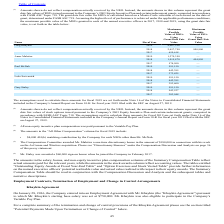According to Viavi Solutions's financial document, How much was Gary Staley's sign-on bonus when he joined the company in February 2017? According to the financial document, $60,000 (in thousands). The relevant text states: "(6) Mr. Staley was awarded a $60,000 sign-on bonus when he joined the Company in February 2017...." Also, What was the maximum possible value of MSU's using grant date fair value for Oleg Khaykin in 2018? According to the financial document, 2,457,750. The relevant text states: "2018 2,457,750 909,900..." Also, What was the maximum possible value of MSU's using grant date fair value for Paul McNab in 2019? According to the financial document, 591,150. The relevant text states: "Paul McNab 2019 591,150 —..." Also, can you calculate: What was the change in maximum possible value of MSU's using grant date fair value for Paul McNab between 2017 and 2018 as a percentage? To answer this question, I need to perform calculations using the financial data. The calculation is: (442,395-373,425)/373,425, which equals 18.47 (percentage). This is based on the information: "2017 373,425 — 2018 442,395 —..." The key data points involved are: 373,425, 442,395. Also, can you calculate: What is the difference between the maximum possible value of PSUs in 2018 between Oleg Khaykin and Amar Maletira? Based on the calculation: (909,900-454,950), the result is 454950. This is based on the information: "2018 2,457,750 909,900 2018 1,015,870 454,950..." The key data points involved are: 454,950, 909,900. Also, can you calculate: How much does the top 2 maximum possible value of MSUs in 2019 add up to? Based on the calculation: (4,067,526+1,379,350), the result is 5446876. This is based on the information: "Amar Maletira 2019 1,379,350 — Oleg Khaykin 2019 4,067,526 —..." The key data points involved are: 1,379,350, 4,067,526. 